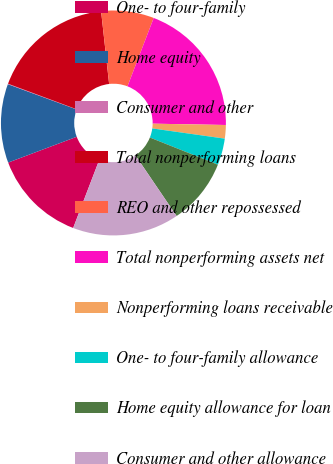Convert chart. <chart><loc_0><loc_0><loc_500><loc_500><pie_chart><fcel>One- to four-family<fcel>Home equity<fcel>Consumer and other<fcel>Total nonperforming loans<fcel>REO and other repossessed<fcel>Total nonperforming assets net<fcel>Nonperforming loans receivable<fcel>One- to four-family allowance<fcel>Home equity allowance for loan<fcel>Consumer and other allowance<nl><fcel>13.45%<fcel>11.33%<fcel>0.07%<fcel>17.58%<fcel>7.58%<fcel>19.46%<fcel>1.94%<fcel>3.82%<fcel>9.46%<fcel>15.32%<nl></chart> 